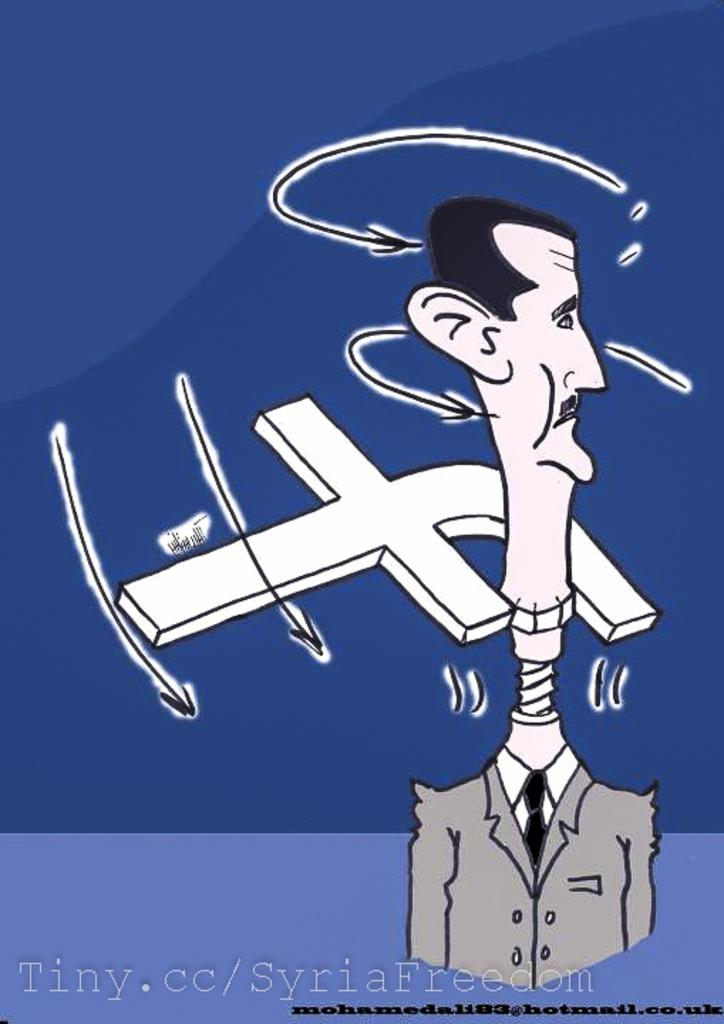What type of image is present in the picture? There is a cartoon image of a person in the image. What else can be seen in the image besides the cartoon person? There are letters and text visible in the image, as well as cloth. Can you hear the ghost laughing in the image? There is no ghost or laughter present in the image; it only contains a cartoon image of a person, letters, text, and cloth. 